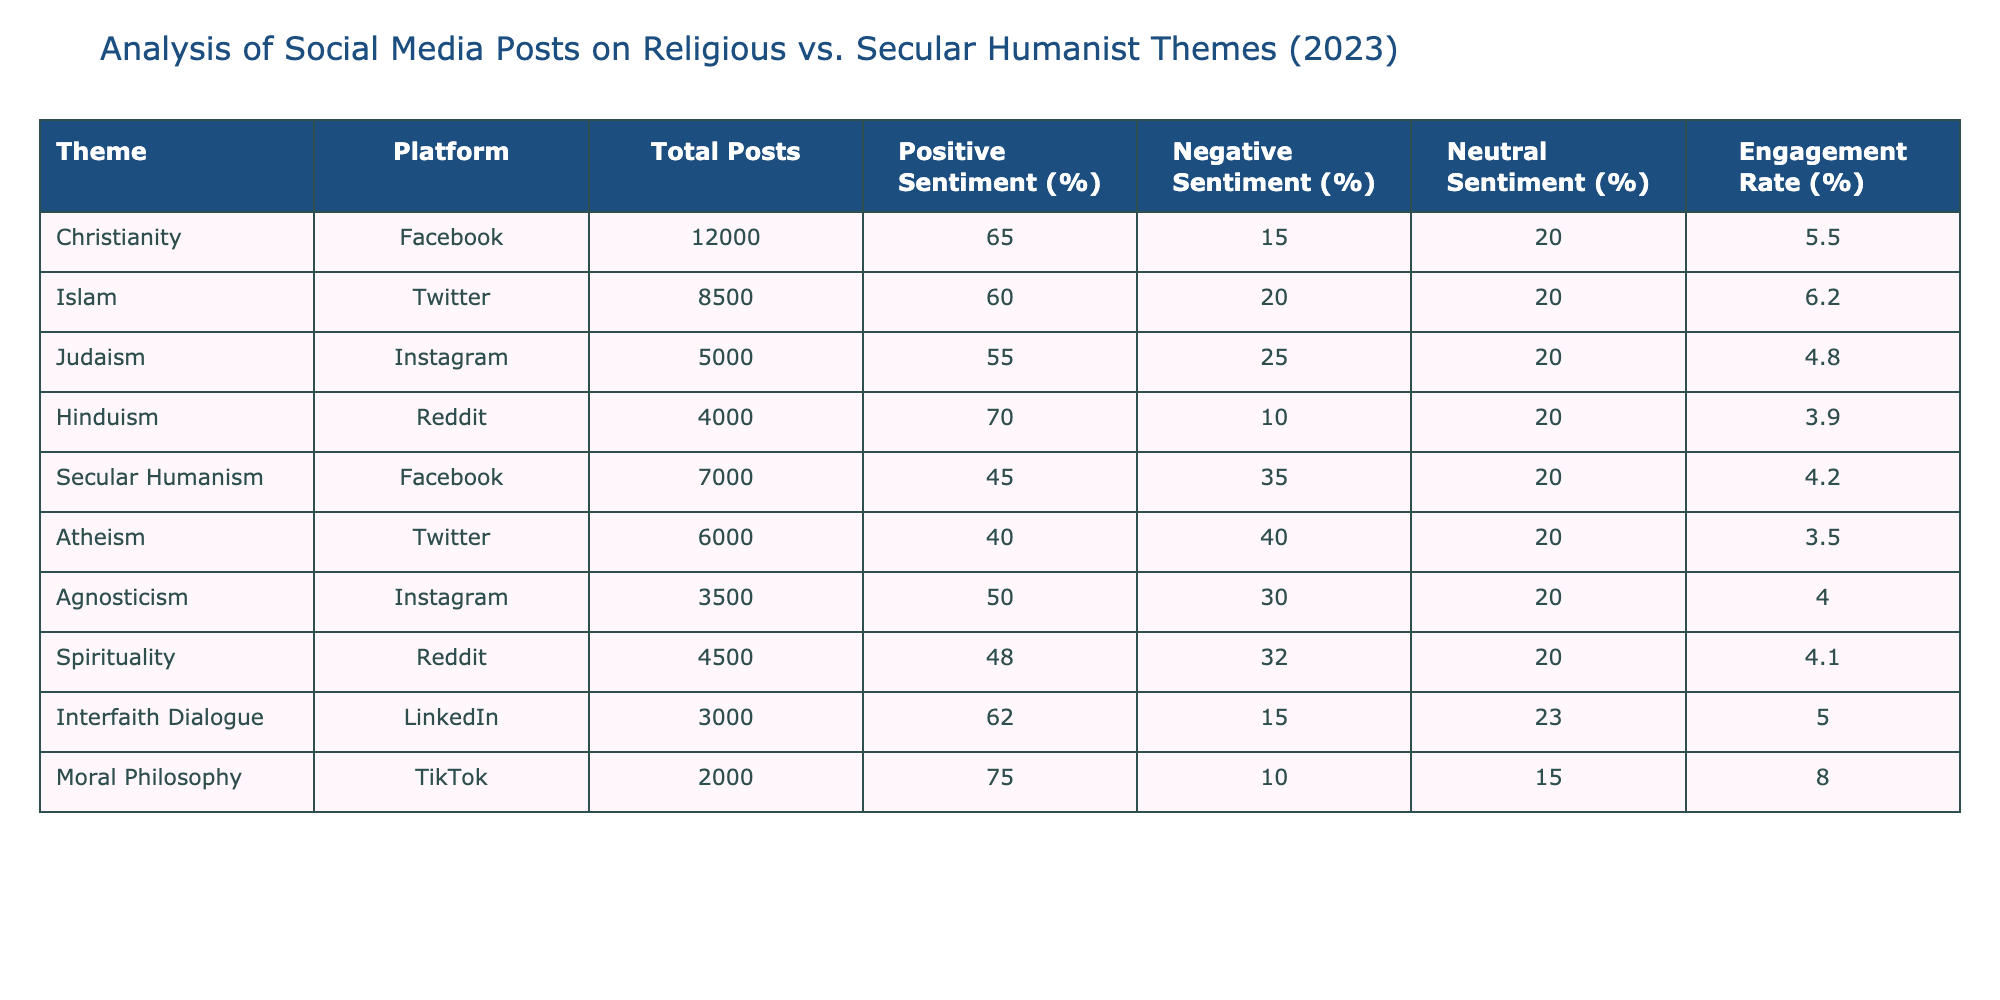What is the total number of posts for Hinduism? In the table, I look at the row for Hinduism, which shows that there are 4000 total posts.
Answer: 4000 Which platform has the highest positive sentiment percentage for Secular Humanism? The table indicates that Facebook has a positive sentiment percentage of 45% for Secular Humanism, as opposed to other platforms which show lower percentages for this theme.
Answer: Facebook What is the engagement rate for Moral Philosophy? Looking at the row for Moral Philosophy, its engagement rate is listed as 8.0%.
Answer: 8.0 What is the average positive sentiment percentage across all themes presented? First, I sum the positive sentiment percentages for each theme: (65 + 60 + 55 + 70 + 45 + 40 + 50 + 48 + 62 + 75) = 570. There are 10 themes, so I divide 570 by 10 to get an average of 57%.
Answer: 57% Is the negative sentiment for Atheism higher than for Judaism? The negative sentiment for Atheism is 40%, while for Judaism it is 25%. Since 40% is higher than 25%, the answer is yes.
Answer: Yes Which theme has the lowest engagement rate? By checking the engagement rates for each theme, I see that Hinduism has the lowest engagement rate at 3.9%.
Answer: Hinduism How many themes have more than 60% positive sentiment? I check the table and see that there are three themes (Christianity, Hinduism, and Moral Philosophy) with positive sentiment percentages above 60%.
Answer: 3 What is the difference in engagement rates between Interfaith Dialogue and Atheism? Interfaith Dialogue has an engagement rate of 5.0% and Atheism has an engagement rate of 3.5%. I subtract 3.5% from 5.0%, which gives a difference of 1.5%.
Answer: 1.5% Is the negative sentiment for Spirituality lower than that of Islam? The negative sentiment for Spirituality is 32%, while for Islam it is 20%. Since 32% is not lower than 20%, the answer is no.
Answer: No What percentage of total posts are from Facebook? The table shows a total of 12000 (Christianity) + 7000 (Secular Humanism) = 19000 posts from Facebook. The overall total posts count across all themes is 37000. I calculate (19000/37000) * 100% to get about 51.35%.
Answer: 51.35% 